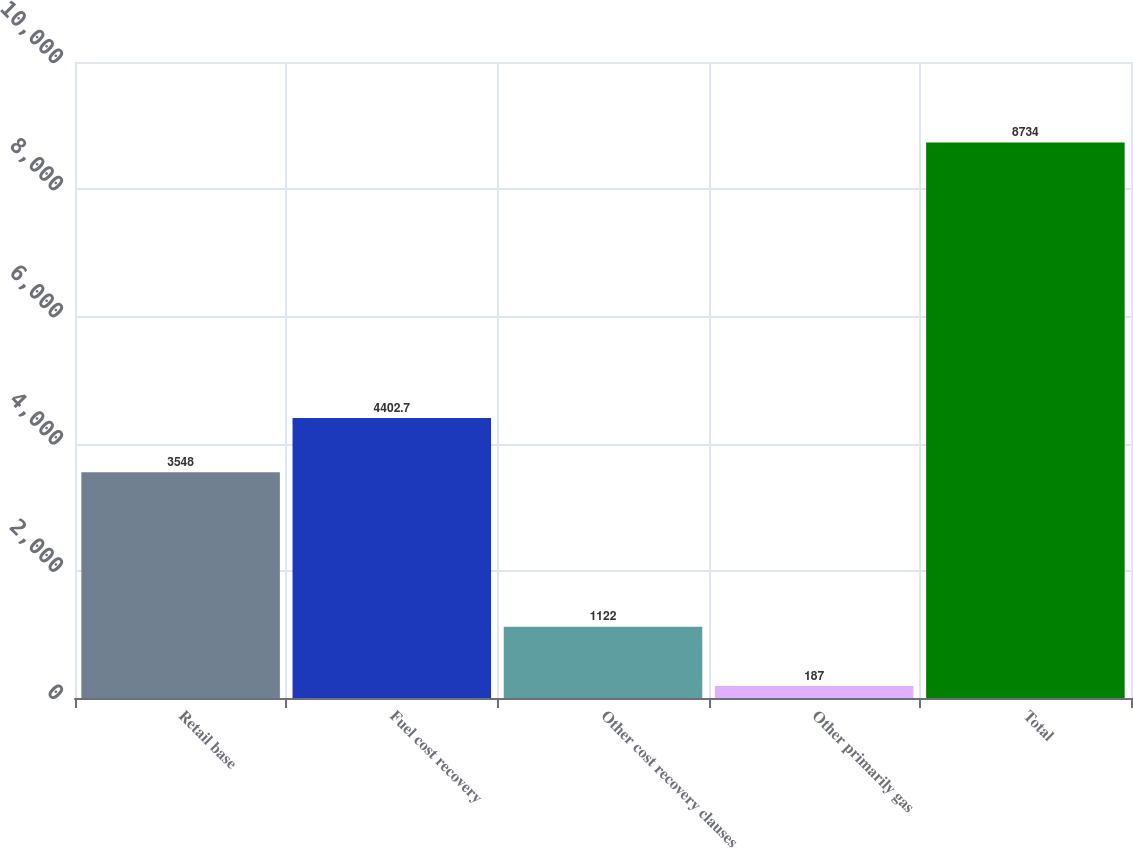Convert chart to OTSL. <chart><loc_0><loc_0><loc_500><loc_500><bar_chart><fcel>Retail base<fcel>Fuel cost recovery<fcel>Other cost recovery clauses<fcel>Other primarily gas<fcel>Total<nl><fcel>3548<fcel>4402.7<fcel>1122<fcel>187<fcel>8734<nl></chart> 